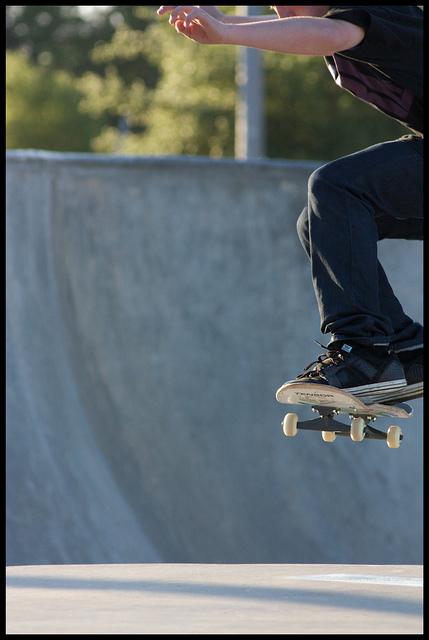What color shoes is he wearing?
Concise answer only. Black. How many wheels are on the skateboard?
Quick response, please. 4. What sport is this?
Keep it brief. Skateboarding. How high is the skateboard off of the ground?
Concise answer only. 1 foot. What is the young man doing?
Short answer required. Skateboarding. 